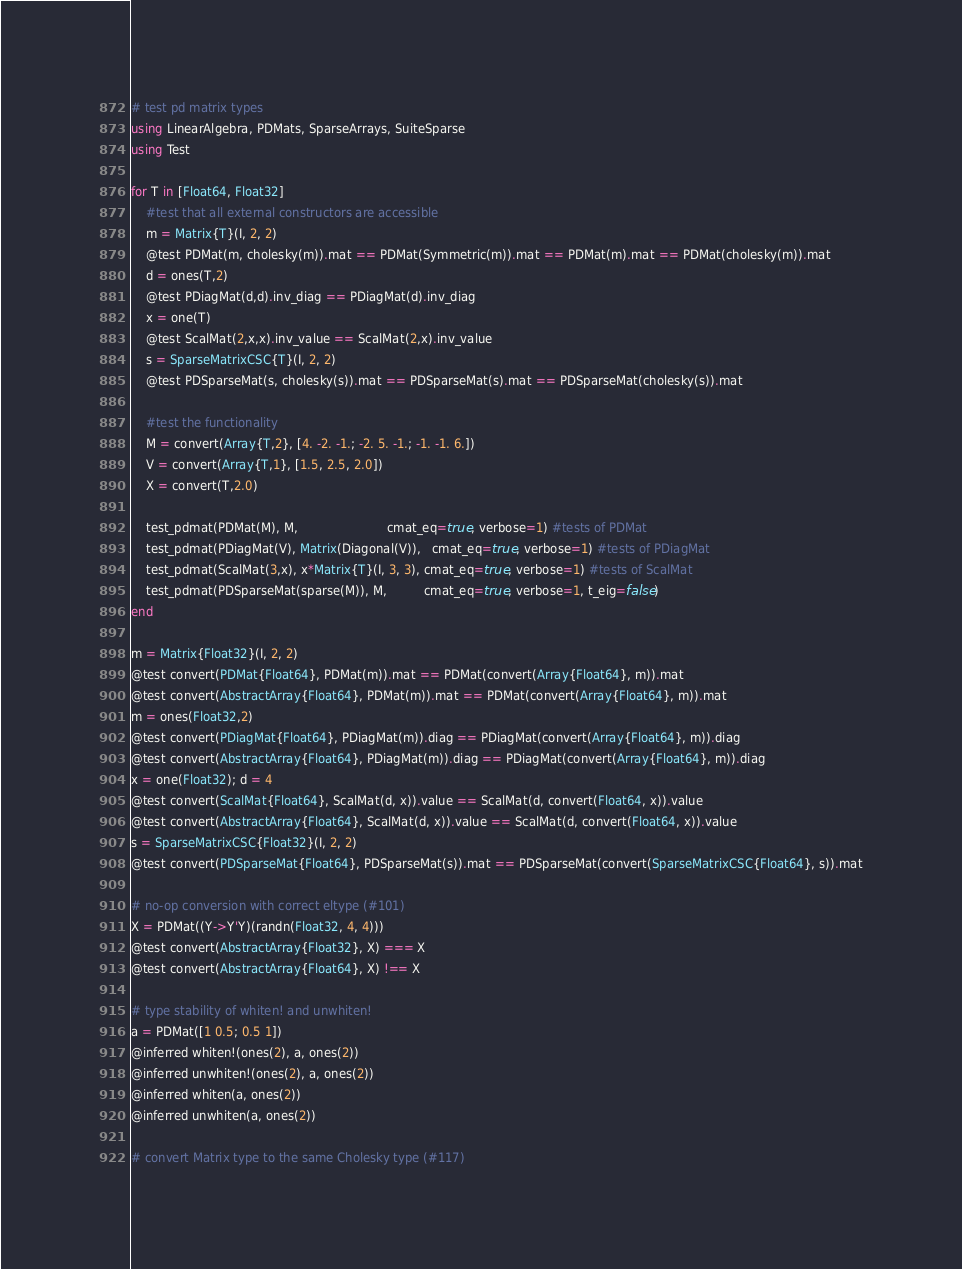Convert code to text. <code><loc_0><loc_0><loc_500><loc_500><_Julia_># test pd matrix types
using LinearAlgebra, PDMats, SparseArrays, SuiteSparse
using Test

for T in [Float64, Float32]
    #test that all external constructors are accessible
    m = Matrix{T}(I, 2, 2)
    @test PDMat(m, cholesky(m)).mat == PDMat(Symmetric(m)).mat == PDMat(m).mat == PDMat(cholesky(m)).mat
    d = ones(T,2)
    @test PDiagMat(d,d).inv_diag == PDiagMat(d).inv_diag
    x = one(T)
    @test ScalMat(2,x,x).inv_value == ScalMat(2,x).inv_value
    s = SparseMatrixCSC{T}(I, 2, 2)
    @test PDSparseMat(s, cholesky(s)).mat == PDSparseMat(s).mat == PDSparseMat(cholesky(s)).mat

    #test the functionality
    M = convert(Array{T,2}, [4. -2. -1.; -2. 5. -1.; -1. -1. 6.])
    V = convert(Array{T,1}, [1.5, 2.5, 2.0])
    X = convert(T,2.0)

    test_pdmat(PDMat(M), M,                        cmat_eq=true, verbose=1) #tests of PDMat
    test_pdmat(PDiagMat(V), Matrix(Diagonal(V)),   cmat_eq=true, verbose=1) #tests of PDiagMat
    test_pdmat(ScalMat(3,x), x*Matrix{T}(I, 3, 3), cmat_eq=true, verbose=1) #tests of ScalMat
    test_pdmat(PDSparseMat(sparse(M)), M,          cmat_eq=true, verbose=1, t_eig=false)
end

m = Matrix{Float32}(I, 2, 2)
@test convert(PDMat{Float64}, PDMat(m)).mat == PDMat(convert(Array{Float64}, m)).mat
@test convert(AbstractArray{Float64}, PDMat(m)).mat == PDMat(convert(Array{Float64}, m)).mat
m = ones(Float32,2)
@test convert(PDiagMat{Float64}, PDiagMat(m)).diag == PDiagMat(convert(Array{Float64}, m)).diag
@test convert(AbstractArray{Float64}, PDiagMat(m)).diag == PDiagMat(convert(Array{Float64}, m)).diag
x = one(Float32); d = 4
@test convert(ScalMat{Float64}, ScalMat(d, x)).value == ScalMat(d, convert(Float64, x)).value
@test convert(AbstractArray{Float64}, ScalMat(d, x)).value == ScalMat(d, convert(Float64, x)).value
s = SparseMatrixCSC{Float32}(I, 2, 2)
@test convert(PDSparseMat{Float64}, PDSparseMat(s)).mat == PDSparseMat(convert(SparseMatrixCSC{Float64}, s)).mat

# no-op conversion with correct eltype (#101)
X = PDMat((Y->Y'Y)(randn(Float32, 4, 4)))
@test convert(AbstractArray{Float32}, X) === X
@test convert(AbstractArray{Float64}, X) !== X

# type stability of whiten! and unwhiten!
a = PDMat([1 0.5; 0.5 1])
@inferred whiten!(ones(2), a, ones(2))
@inferred unwhiten!(ones(2), a, ones(2))
@inferred whiten(a, ones(2))
@inferred unwhiten(a, ones(2))

# convert Matrix type to the same Cholesky type (#117)</code> 